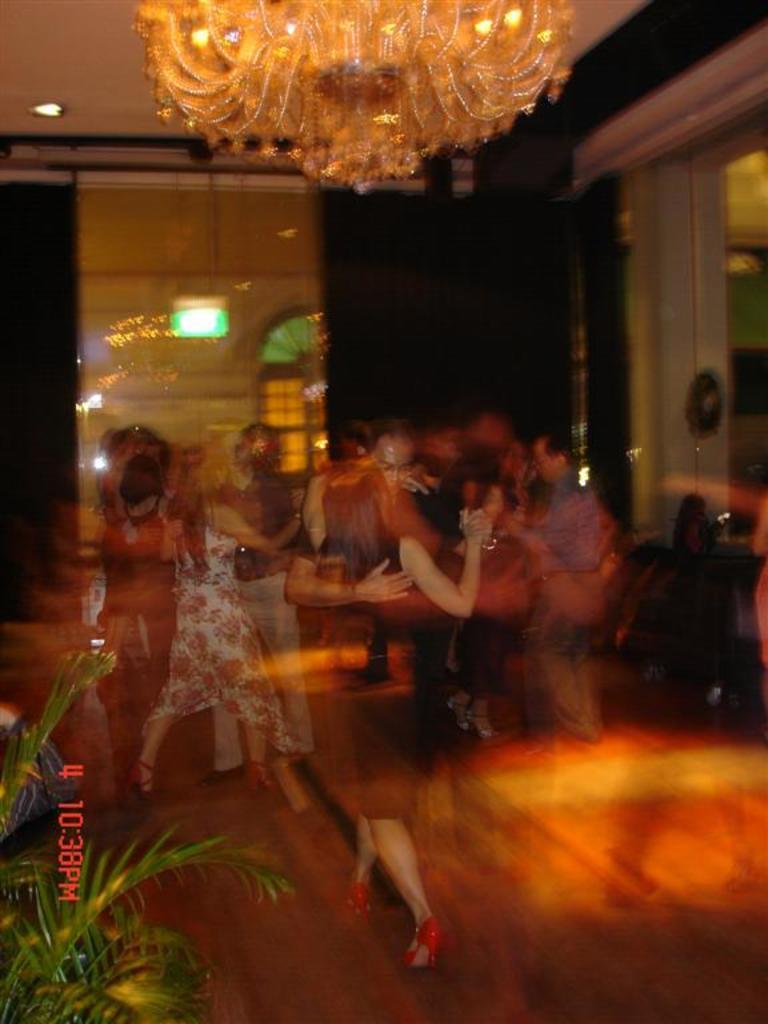How would you summarize this image in a sentence or two? In the center of the image we can see people dancing. At the top there is a chandelier. At the bottom there is a plant. In the background there is a wall. 